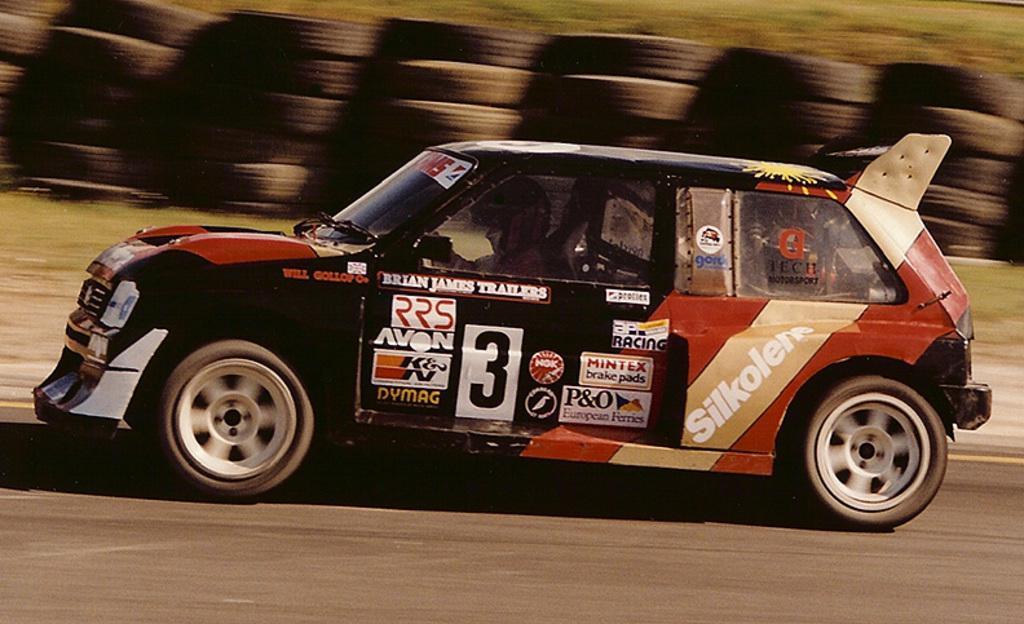Could you give a brief overview of what you see in this image? In the image we can see a vehicle, riding on the road. In the vehicle there is a person sitting, this is a grass and these are the tires. 